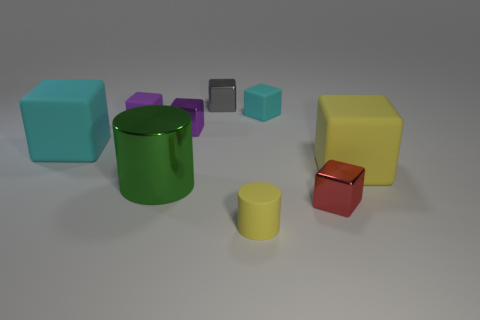Subtract all small metallic cubes. How many cubes are left? 4 Subtract 4 blocks. How many blocks are left? 3 Subtract all yellow blocks. How many blocks are left? 6 Add 1 big yellow matte blocks. How many objects exist? 10 Subtract all red cubes. Subtract all brown cylinders. How many cubes are left? 6 Subtract all cylinders. How many objects are left? 7 Subtract 0 brown blocks. How many objects are left? 9 Subtract all tiny cyan rubber balls. Subtract all tiny blocks. How many objects are left? 4 Add 8 red blocks. How many red blocks are left? 9 Add 5 tiny red metallic objects. How many tiny red metallic objects exist? 6 